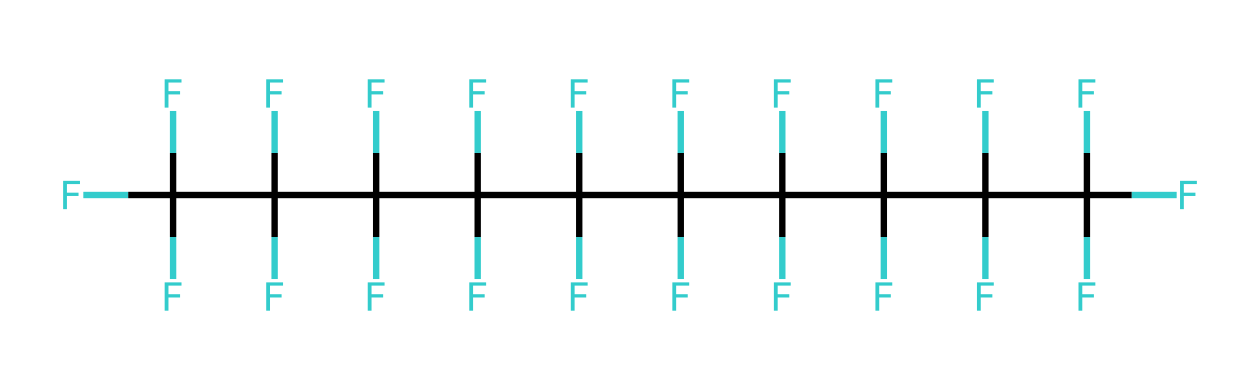What is the total number of carbon atoms in this chemical? By examining the SMILES representation, we count 10 "C" atoms that indicate the number of carbon atoms present in the molecule.
Answer: 10 How many fluorine atoms are in this structure? The SMILES contains "F" in multiple places, totaling 21 occurrences of the letter, indicating there are 21 fluorine atoms in the chemical structure.
Answer: 21 What is the chemical formula based on the structure? From the counts of carbon and fluorine observed in the SMILES, the overall chemical formula can be determined to be C10F21, reflecting the ratio of carbon to fluorine atoms.
Answer: C10F21 What type of chemical bonding is predominantly present in this compound? The extensive presence of fluorine and carbon suggests the molecule is largely held together by covalent bonds, as both elements share pairs of electrons in this context.
Answer: covalent What property makes fluorinated oils suitable for spacecraft lubrication? The low surface tension and non-reactivity of fluorinated oils reduce friction and inhibit chemical reactions with spacecraft materials, making them ideal for high-performance lubrication in extreme environments.
Answer: non-reactivity How does the structure contribute to the lubricant's thermal stability? The presence of strong C-F bonds in the chemical structure contributes to the overall thermal stability, as these bonds are significantly stronger than C-H bonds found in conventional lubricants, allowing the oil to maintain performance at higher temperatures.
Answer: strong C-F bonds What is the significance of having a fully fluorinated structure for lubricants? A fully fluorinated structure ensures that the lubricant is non-flammable and has low volatility, minimizing evaporation and degradation under the harsh conditions experienced in space.
Answer: non-flammable 